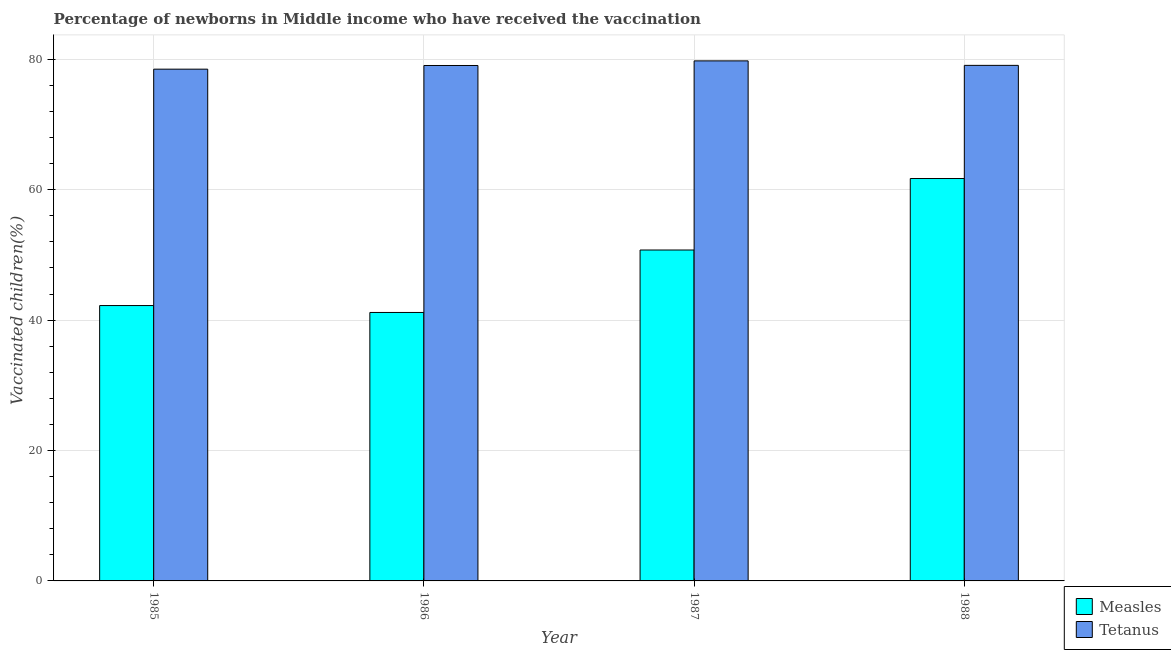How many different coloured bars are there?
Ensure brevity in your answer.  2. How many groups of bars are there?
Keep it short and to the point. 4. What is the label of the 1st group of bars from the left?
Offer a terse response. 1985. In how many cases, is the number of bars for a given year not equal to the number of legend labels?
Ensure brevity in your answer.  0. What is the percentage of newborns who received vaccination for tetanus in 1986?
Your answer should be very brief. 79.04. Across all years, what is the maximum percentage of newborns who received vaccination for tetanus?
Your answer should be compact. 79.75. Across all years, what is the minimum percentage of newborns who received vaccination for tetanus?
Make the answer very short. 78.48. In which year was the percentage of newborns who received vaccination for measles minimum?
Ensure brevity in your answer.  1986. What is the total percentage of newborns who received vaccination for measles in the graph?
Your response must be concise. 195.85. What is the difference between the percentage of newborns who received vaccination for measles in 1987 and that in 1988?
Offer a very short reply. -10.96. What is the difference between the percentage of newborns who received vaccination for tetanus in 1986 and the percentage of newborns who received vaccination for measles in 1987?
Offer a very short reply. -0.71. What is the average percentage of newborns who received vaccination for tetanus per year?
Keep it short and to the point. 79.08. What is the ratio of the percentage of newborns who received vaccination for measles in 1985 to that in 1987?
Give a very brief answer. 0.83. Is the difference between the percentage of newborns who received vaccination for tetanus in 1987 and 1988 greater than the difference between the percentage of newborns who received vaccination for measles in 1987 and 1988?
Keep it short and to the point. No. What is the difference between the highest and the second highest percentage of newborns who received vaccination for tetanus?
Your answer should be compact. 0.69. What is the difference between the highest and the lowest percentage of newborns who received vaccination for tetanus?
Provide a succinct answer. 1.27. What does the 1st bar from the left in 1988 represents?
Offer a very short reply. Measles. What does the 1st bar from the right in 1985 represents?
Offer a terse response. Tetanus. How many bars are there?
Offer a very short reply. 8. What is the difference between two consecutive major ticks on the Y-axis?
Offer a very short reply. 20. Where does the legend appear in the graph?
Keep it short and to the point. Bottom right. How are the legend labels stacked?
Provide a short and direct response. Vertical. What is the title of the graph?
Your response must be concise. Percentage of newborns in Middle income who have received the vaccination. What is the label or title of the Y-axis?
Provide a short and direct response. Vaccinated children(%)
. What is the Vaccinated children(%)
 of Measles in 1985?
Make the answer very short. 42.23. What is the Vaccinated children(%)
 in Tetanus in 1985?
Offer a terse response. 78.48. What is the Vaccinated children(%)
 of Measles in 1986?
Provide a succinct answer. 41.17. What is the Vaccinated children(%)
 in Tetanus in 1986?
Your response must be concise. 79.04. What is the Vaccinated children(%)
 in Measles in 1987?
Your answer should be very brief. 50.75. What is the Vaccinated children(%)
 in Tetanus in 1987?
Your response must be concise. 79.75. What is the Vaccinated children(%)
 in Measles in 1988?
Offer a very short reply. 61.71. What is the Vaccinated children(%)
 of Tetanus in 1988?
Your response must be concise. 79.06. Across all years, what is the maximum Vaccinated children(%)
 of Measles?
Provide a short and direct response. 61.71. Across all years, what is the maximum Vaccinated children(%)
 of Tetanus?
Provide a succinct answer. 79.75. Across all years, what is the minimum Vaccinated children(%)
 in Measles?
Provide a short and direct response. 41.17. Across all years, what is the minimum Vaccinated children(%)
 in Tetanus?
Keep it short and to the point. 78.48. What is the total Vaccinated children(%)
 of Measles in the graph?
Provide a short and direct response. 195.85. What is the total Vaccinated children(%)
 of Tetanus in the graph?
Your answer should be compact. 316.34. What is the difference between the Vaccinated children(%)
 of Measles in 1985 and that in 1986?
Make the answer very short. 1.06. What is the difference between the Vaccinated children(%)
 of Tetanus in 1985 and that in 1986?
Your response must be concise. -0.56. What is the difference between the Vaccinated children(%)
 in Measles in 1985 and that in 1987?
Make the answer very short. -8.52. What is the difference between the Vaccinated children(%)
 of Tetanus in 1985 and that in 1987?
Provide a succinct answer. -1.27. What is the difference between the Vaccinated children(%)
 of Measles in 1985 and that in 1988?
Offer a very short reply. -19.48. What is the difference between the Vaccinated children(%)
 in Tetanus in 1985 and that in 1988?
Offer a terse response. -0.58. What is the difference between the Vaccinated children(%)
 in Measles in 1986 and that in 1987?
Your answer should be very brief. -9.58. What is the difference between the Vaccinated children(%)
 of Tetanus in 1986 and that in 1987?
Make the answer very short. -0.71. What is the difference between the Vaccinated children(%)
 of Measles in 1986 and that in 1988?
Your answer should be compact. -20.54. What is the difference between the Vaccinated children(%)
 in Tetanus in 1986 and that in 1988?
Your response must be concise. -0.02. What is the difference between the Vaccinated children(%)
 in Measles in 1987 and that in 1988?
Keep it short and to the point. -10.96. What is the difference between the Vaccinated children(%)
 in Tetanus in 1987 and that in 1988?
Provide a short and direct response. 0.69. What is the difference between the Vaccinated children(%)
 of Measles in 1985 and the Vaccinated children(%)
 of Tetanus in 1986?
Your answer should be compact. -36.82. What is the difference between the Vaccinated children(%)
 in Measles in 1985 and the Vaccinated children(%)
 in Tetanus in 1987?
Offer a very short reply. -37.52. What is the difference between the Vaccinated children(%)
 in Measles in 1985 and the Vaccinated children(%)
 in Tetanus in 1988?
Your answer should be very brief. -36.83. What is the difference between the Vaccinated children(%)
 in Measles in 1986 and the Vaccinated children(%)
 in Tetanus in 1987?
Provide a succinct answer. -38.58. What is the difference between the Vaccinated children(%)
 in Measles in 1986 and the Vaccinated children(%)
 in Tetanus in 1988?
Your response must be concise. -37.89. What is the difference between the Vaccinated children(%)
 of Measles in 1987 and the Vaccinated children(%)
 of Tetanus in 1988?
Give a very brief answer. -28.32. What is the average Vaccinated children(%)
 of Measles per year?
Keep it short and to the point. 48.96. What is the average Vaccinated children(%)
 of Tetanus per year?
Ensure brevity in your answer.  79.08. In the year 1985, what is the difference between the Vaccinated children(%)
 of Measles and Vaccinated children(%)
 of Tetanus?
Keep it short and to the point. -36.25. In the year 1986, what is the difference between the Vaccinated children(%)
 of Measles and Vaccinated children(%)
 of Tetanus?
Provide a succinct answer. -37.87. In the year 1987, what is the difference between the Vaccinated children(%)
 of Measles and Vaccinated children(%)
 of Tetanus?
Give a very brief answer. -29. In the year 1988, what is the difference between the Vaccinated children(%)
 of Measles and Vaccinated children(%)
 of Tetanus?
Offer a terse response. -17.35. What is the ratio of the Vaccinated children(%)
 of Measles in 1985 to that in 1986?
Provide a short and direct response. 1.03. What is the ratio of the Vaccinated children(%)
 in Tetanus in 1985 to that in 1986?
Give a very brief answer. 0.99. What is the ratio of the Vaccinated children(%)
 in Measles in 1985 to that in 1987?
Your answer should be very brief. 0.83. What is the ratio of the Vaccinated children(%)
 of Tetanus in 1985 to that in 1987?
Your answer should be very brief. 0.98. What is the ratio of the Vaccinated children(%)
 of Measles in 1985 to that in 1988?
Offer a very short reply. 0.68. What is the ratio of the Vaccinated children(%)
 in Measles in 1986 to that in 1987?
Your answer should be compact. 0.81. What is the ratio of the Vaccinated children(%)
 in Measles in 1986 to that in 1988?
Your answer should be very brief. 0.67. What is the ratio of the Vaccinated children(%)
 in Tetanus in 1986 to that in 1988?
Give a very brief answer. 1. What is the ratio of the Vaccinated children(%)
 in Measles in 1987 to that in 1988?
Your answer should be very brief. 0.82. What is the ratio of the Vaccinated children(%)
 of Tetanus in 1987 to that in 1988?
Give a very brief answer. 1.01. What is the difference between the highest and the second highest Vaccinated children(%)
 in Measles?
Provide a succinct answer. 10.96. What is the difference between the highest and the second highest Vaccinated children(%)
 of Tetanus?
Provide a short and direct response. 0.69. What is the difference between the highest and the lowest Vaccinated children(%)
 in Measles?
Provide a short and direct response. 20.54. What is the difference between the highest and the lowest Vaccinated children(%)
 in Tetanus?
Give a very brief answer. 1.27. 